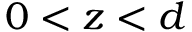<formula> <loc_0><loc_0><loc_500><loc_500>0 < z < d</formula> 